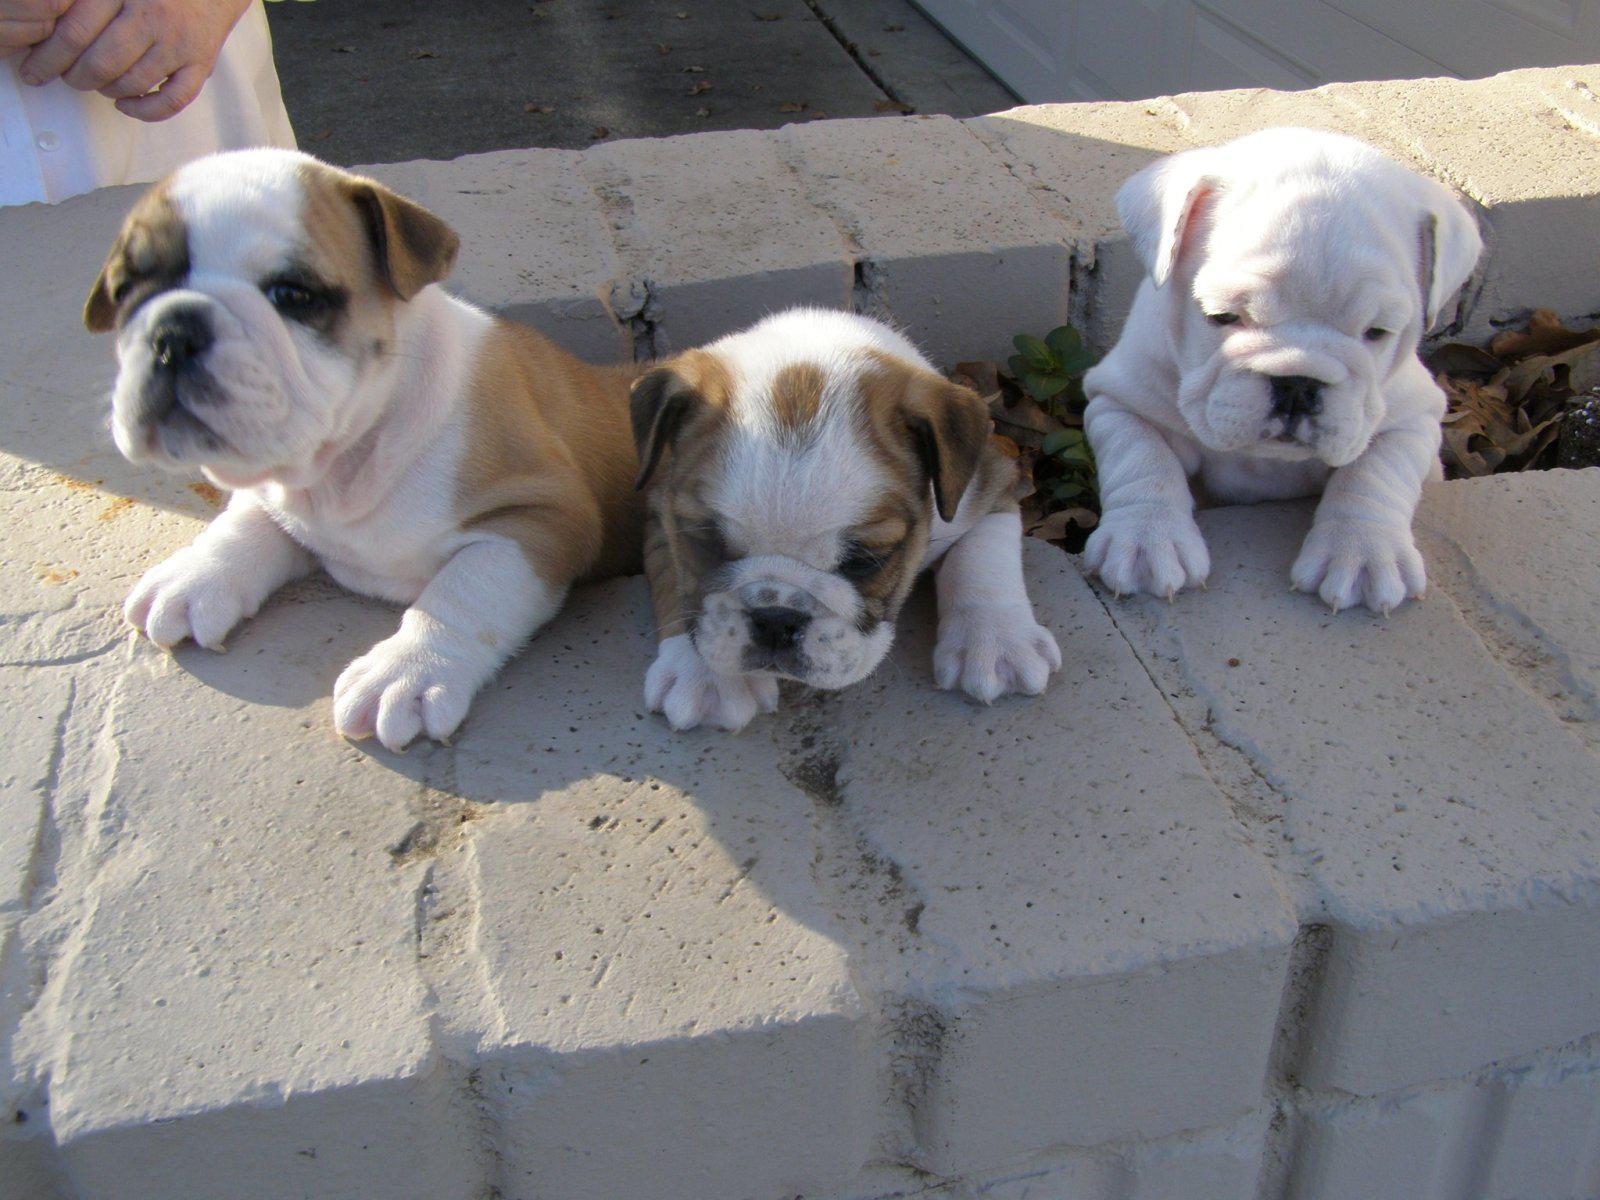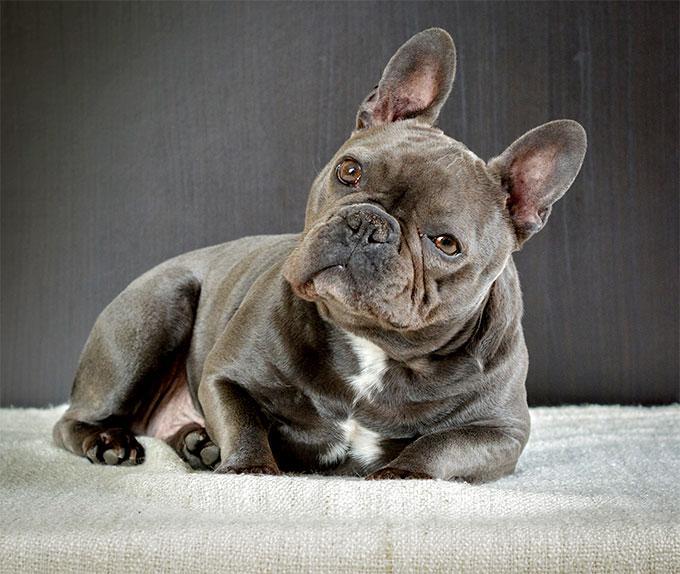The first image is the image on the left, the second image is the image on the right. Given the left and right images, does the statement "One tan dog and one black and white dog are shown." hold true? Answer yes or no. No. 